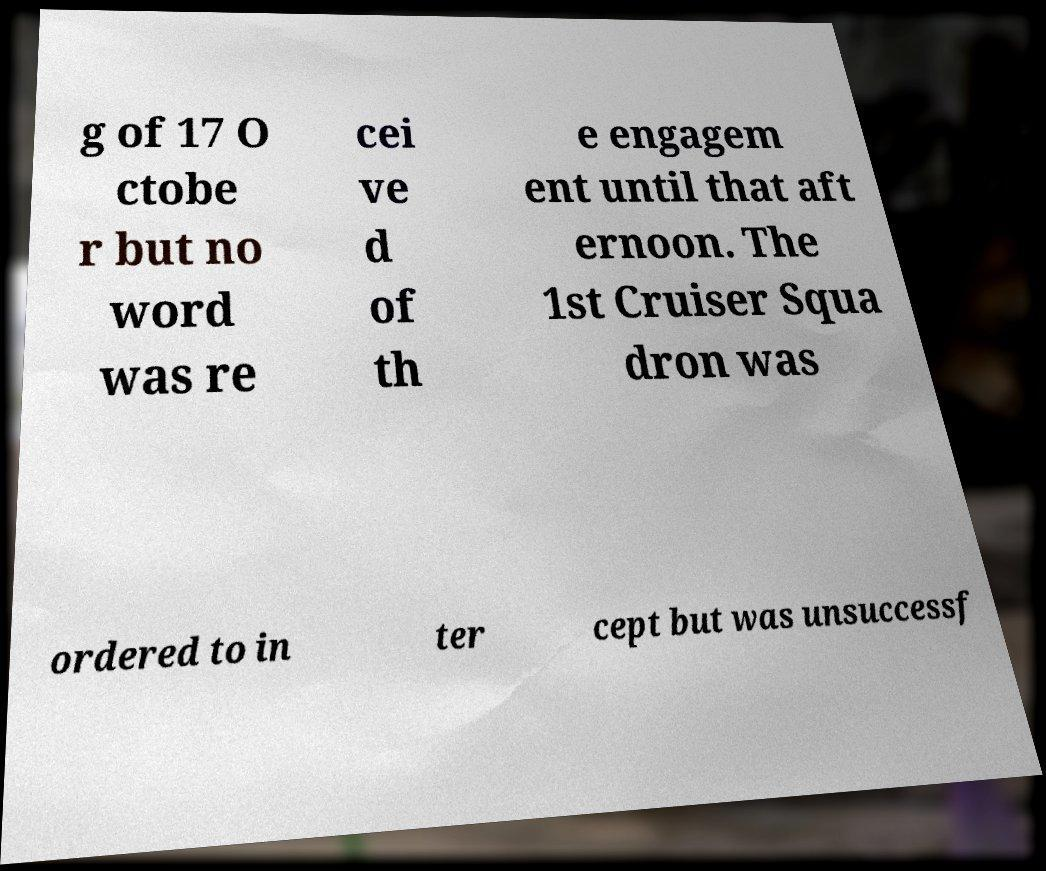Can you read and provide the text displayed in the image?This photo seems to have some interesting text. Can you extract and type it out for me? g of 17 O ctobe r but no word was re cei ve d of th e engagem ent until that aft ernoon. The 1st Cruiser Squa dron was ordered to in ter cept but was unsuccessf 